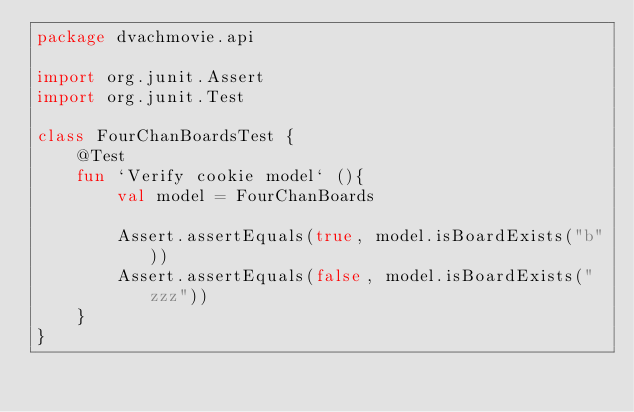Convert code to text. <code><loc_0><loc_0><loc_500><loc_500><_Kotlin_>package dvachmovie.api

import org.junit.Assert
import org.junit.Test

class FourChanBoardsTest {
    @Test
    fun `Verify cookie model` (){
        val model = FourChanBoards

        Assert.assertEquals(true, model.isBoardExists("b"))
        Assert.assertEquals(false, model.isBoardExists("zzz"))
    }
}
</code> 